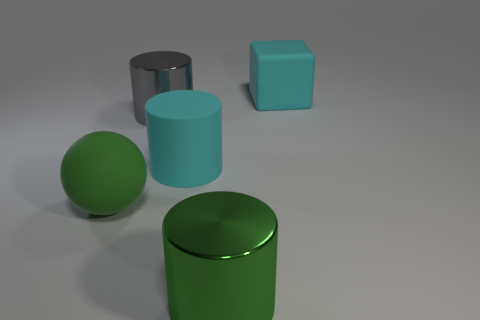Subtract all big metallic cylinders. How many cylinders are left? 1 Subtract 1 spheres. How many spheres are left? 0 Add 5 big shiny things. How many objects exist? 10 Subtract all balls. How many objects are left? 4 Subtract all green cylinders. How many cylinders are left? 2 Subtract all green spheres. How many gray cylinders are left? 1 Subtract all large cyan metallic things. Subtract all big cyan objects. How many objects are left? 3 Add 1 green balls. How many green balls are left? 2 Add 2 metallic objects. How many metallic objects exist? 4 Subtract 0 gray blocks. How many objects are left? 5 